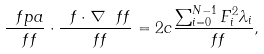<formula> <loc_0><loc_0><loc_500><loc_500>\frac { \ f p a } { \ f f } \cdot \frac { \ f \cdot \nabla \ f f } { \ f f } = 2 c \frac { \sum _ { i = 0 } ^ { N - 1 } F _ { i } ^ { 2 } \lambda _ { i } } { \ f f } ,</formula> 